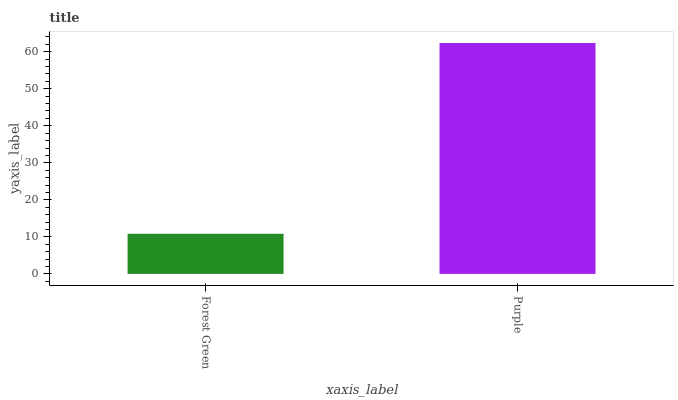Is Forest Green the minimum?
Answer yes or no. Yes. Is Purple the maximum?
Answer yes or no. Yes. Is Purple the minimum?
Answer yes or no. No. Is Purple greater than Forest Green?
Answer yes or no. Yes. Is Forest Green less than Purple?
Answer yes or no. Yes. Is Forest Green greater than Purple?
Answer yes or no. No. Is Purple less than Forest Green?
Answer yes or no. No. Is Purple the high median?
Answer yes or no. Yes. Is Forest Green the low median?
Answer yes or no. Yes. Is Forest Green the high median?
Answer yes or no. No. Is Purple the low median?
Answer yes or no. No. 